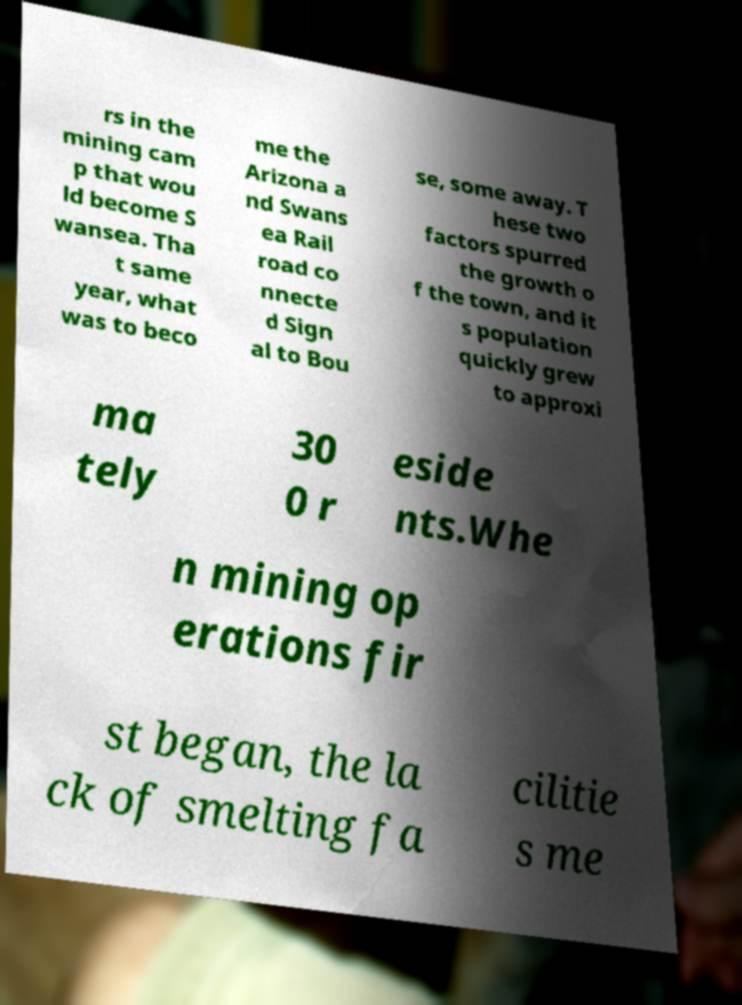What messages or text are displayed in this image? I need them in a readable, typed format. rs in the mining cam p that wou ld become S wansea. Tha t same year, what was to beco me the Arizona a nd Swans ea Rail road co nnecte d Sign al to Bou se, some away. T hese two factors spurred the growth o f the town, and it s population quickly grew to approxi ma tely 30 0 r eside nts.Whe n mining op erations fir st began, the la ck of smelting fa cilitie s me 